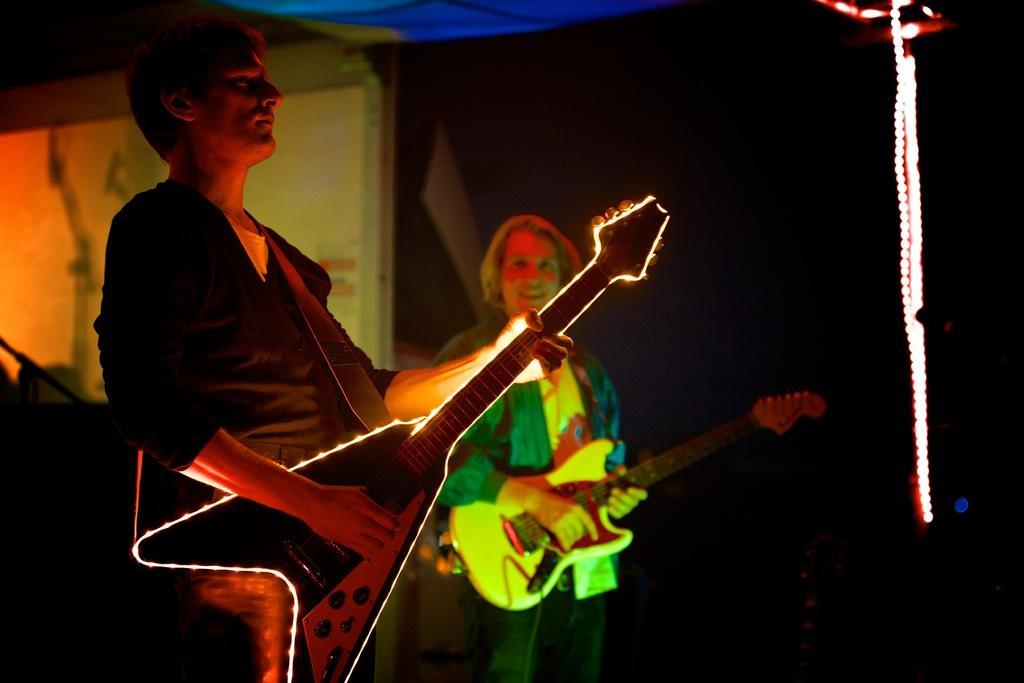Please provide a concise description of this image. In this image I can see two people standing and they are holding the guitar. 